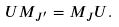Convert formula to latex. <formula><loc_0><loc_0><loc_500><loc_500>U M _ { J ^ { \prime } } = M _ { J } U .</formula> 